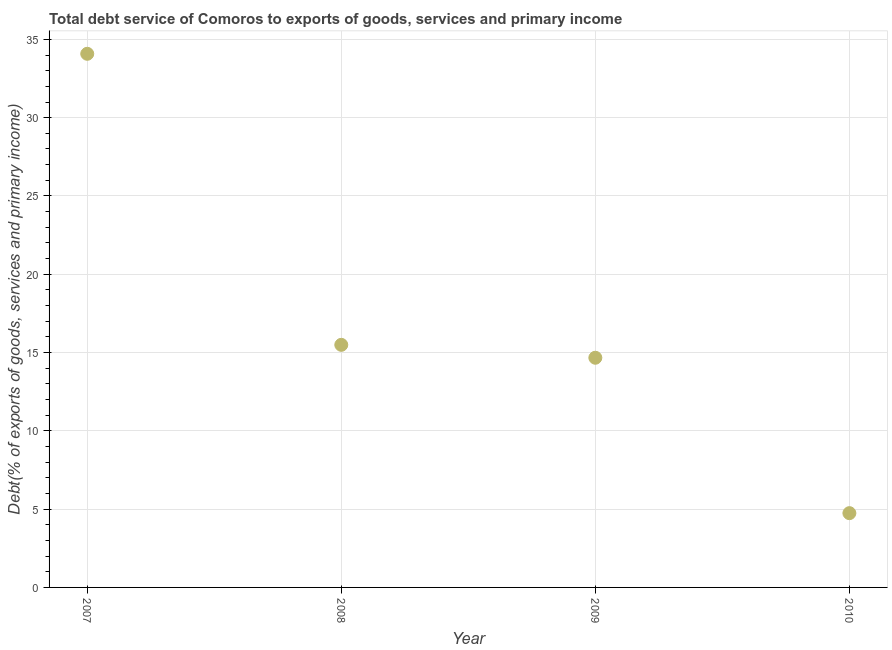What is the total debt service in 2007?
Keep it short and to the point. 34.08. Across all years, what is the maximum total debt service?
Give a very brief answer. 34.08. Across all years, what is the minimum total debt service?
Your answer should be compact. 4.74. In which year was the total debt service maximum?
Provide a succinct answer. 2007. What is the sum of the total debt service?
Offer a very short reply. 68.98. What is the difference between the total debt service in 2009 and 2010?
Provide a succinct answer. 9.92. What is the average total debt service per year?
Give a very brief answer. 17.25. What is the median total debt service?
Provide a succinct answer. 15.08. What is the ratio of the total debt service in 2008 to that in 2010?
Provide a short and direct response. 3.27. Is the total debt service in 2008 less than that in 2009?
Make the answer very short. No. What is the difference between the highest and the second highest total debt service?
Provide a succinct answer. 18.59. What is the difference between the highest and the lowest total debt service?
Give a very brief answer. 29.34. How many dotlines are there?
Your answer should be very brief. 1. How many years are there in the graph?
Give a very brief answer. 4. What is the difference between two consecutive major ticks on the Y-axis?
Provide a succinct answer. 5. Are the values on the major ticks of Y-axis written in scientific E-notation?
Make the answer very short. No. What is the title of the graph?
Your answer should be compact. Total debt service of Comoros to exports of goods, services and primary income. What is the label or title of the Y-axis?
Provide a short and direct response. Debt(% of exports of goods, services and primary income). What is the Debt(% of exports of goods, services and primary income) in 2007?
Provide a succinct answer. 34.08. What is the Debt(% of exports of goods, services and primary income) in 2008?
Give a very brief answer. 15.49. What is the Debt(% of exports of goods, services and primary income) in 2009?
Your answer should be compact. 14.67. What is the Debt(% of exports of goods, services and primary income) in 2010?
Provide a short and direct response. 4.74. What is the difference between the Debt(% of exports of goods, services and primary income) in 2007 and 2008?
Provide a succinct answer. 18.59. What is the difference between the Debt(% of exports of goods, services and primary income) in 2007 and 2009?
Give a very brief answer. 19.41. What is the difference between the Debt(% of exports of goods, services and primary income) in 2007 and 2010?
Provide a short and direct response. 29.34. What is the difference between the Debt(% of exports of goods, services and primary income) in 2008 and 2009?
Ensure brevity in your answer.  0.82. What is the difference between the Debt(% of exports of goods, services and primary income) in 2008 and 2010?
Your answer should be very brief. 10.75. What is the difference between the Debt(% of exports of goods, services and primary income) in 2009 and 2010?
Give a very brief answer. 9.92. What is the ratio of the Debt(% of exports of goods, services and primary income) in 2007 to that in 2009?
Keep it short and to the point. 2.32. What is the ratio of the Debt(% of exports of goods, services and primary income) in 2007 to that in 2010?
Provide a succinct answer. 7.18. What is the ratio of the Debt(% of exports of goods, services and primary income) in 2008 to that in 2009?
Provide a short and direct response. 1.06. What is the ratio of the Debt(% of exports of goods, services and primary income) in 2008 to that in 2010?
Offer a very short reply. 3.27. What is the ratio of the Debt(% of exports of goods, services and primary income) in 2009 to that in 2010?
Ensure brevity in your answer.  3.09. 